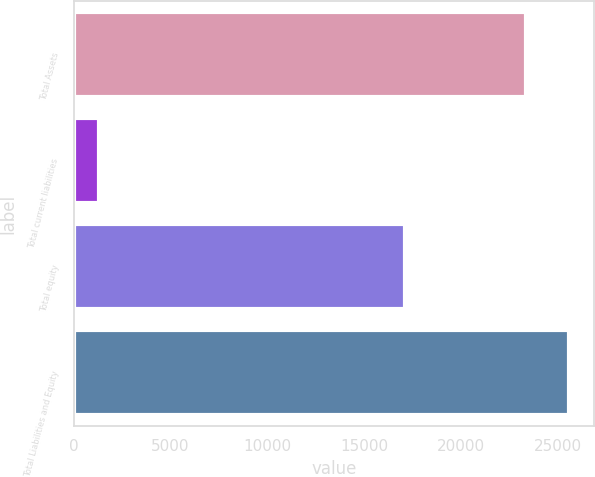<chart> <loc_0><loc_0><loc_500><loc_500><bar_chart><fcel>Total Assets<fcel>Total current liabilities<fcel>Total equity<fcel>Total Liabilities and Equity<nl><fcel>23359.6<fcel>1291.5<fcel>17111.3<fcel>25566.4<nl></chart> 